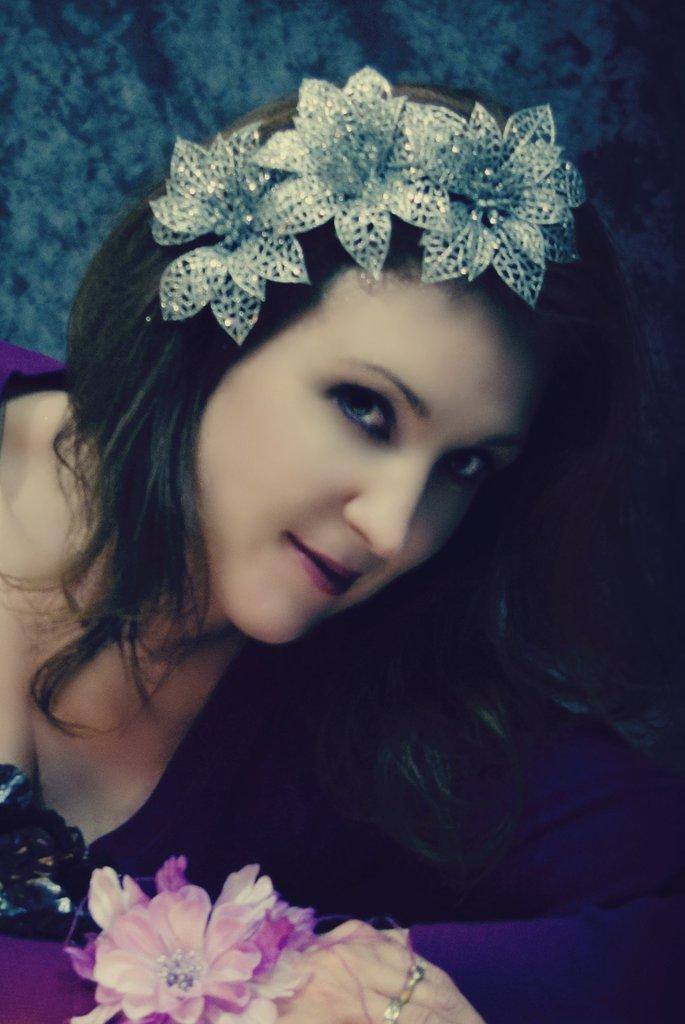Who is present in the image? There is a person in the image. What is the person wearing? The person is wearing a purple dress. What can be seen in the image besides the person? There are flowers in the image. What colors are the flowers? The flowers are white and pink in color. What is the color of the background in the image? The background of the image is green. What type of payment method is being used in the image? There is no payment method present in the image; it features a person wearing a purple dress and flowers. Can you provide an example of a similar dress to the one the person is wearing in the image? It is not possible to provide an example of a similar dress from the image alone, as we cannot see the full design or style of the dress. 